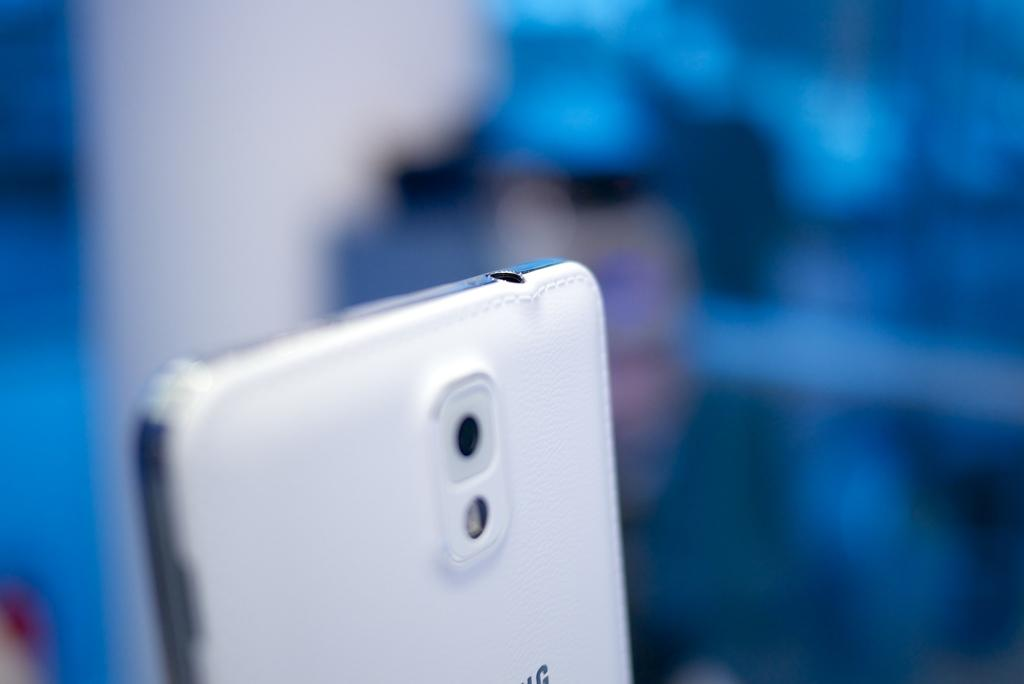What is the main object in the image? There is a mobile in the image. Can you describe the background of the image? The background of the image is blurred. What type of lead can be seen connecting the mobile pieces in the image? There is no lead visible in the image, as it is a mobile with suspended pieces. 